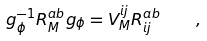<formula> <loc_0><loc_0><loc_500><loc_500>g _ { \phi } ^ { - 1 } R ^ { a b } _ { M } g _ { \phi } = { V } _ { M } ^ { i j } R ^ { a b } _ { i j } \quad ,</formula> 